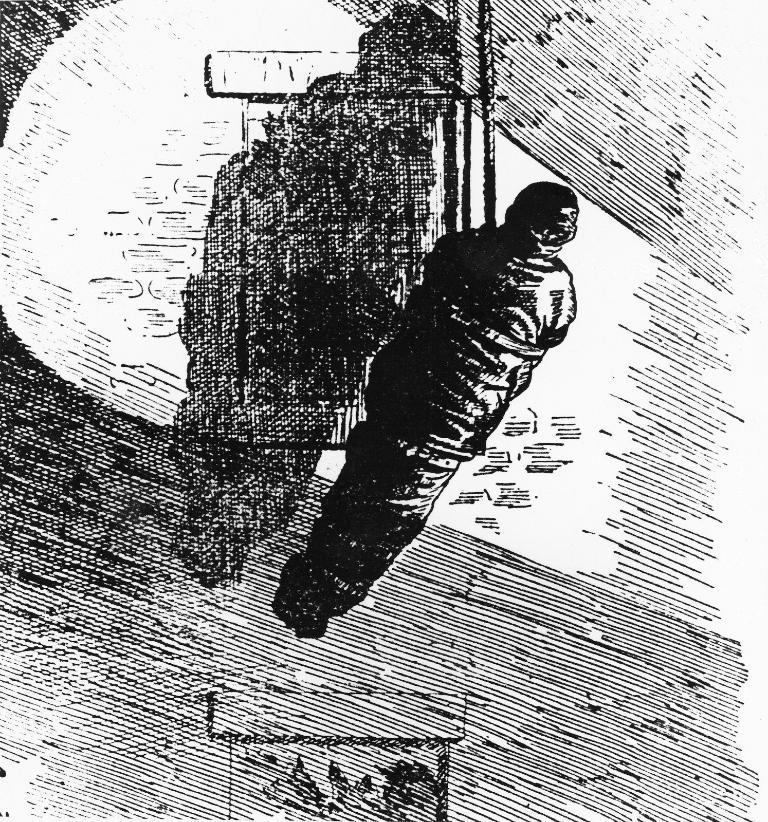Can you describe this image briefly? In this picture it looks like a sketch, in the middle I can see a person is tied with a rope. 